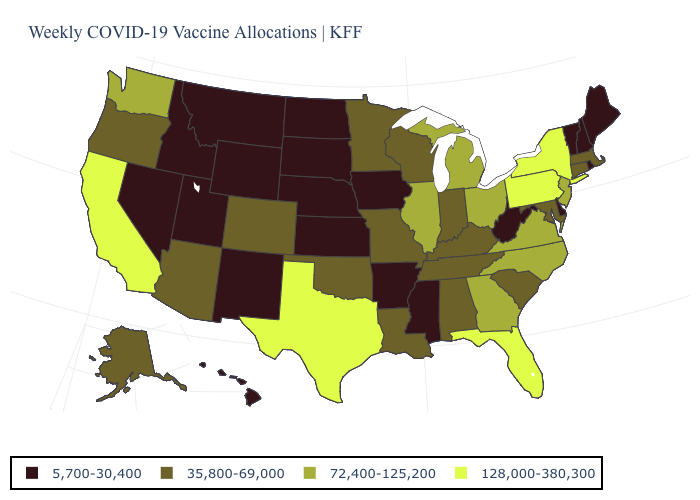What is the value of New York?
Quick response, please. 128,000-380,300. What is the value of Rhode Island?
Concise answer only. 5,700-30,400. Does New Jersey have the same value as Washington?
Be succinct. Yes. What is the value of Ohio?
Quick response, please. 72,400-125,200. Which states have the lowest value in the USA?
Concise answer only. Arkansas, Delaware, Hawaii, Idaho, Iowa, Kansas, Maine, Mississippi, Montana, Nebraska, Nevada, New Hampshire, New Mexico, North Dakota, Rhode Island, South Dakota, Utah, Vermont, West Virginia, Wyoming. Does Pennsylvania have the highest value in the Northeast?
Quick response, please. Yes. Which states hav the highest value in the South?
Short answer required. Florida, Texas. What is the value of California?
Answer briefly. 128,000-380,300. Name the states that have a value in the range 72,400-125,200?
Keep it brief. Georgia, Illinois, Michigan, New Jersey, North Carolina, Ohio, Virginia, Washington. What is the highest value in the Northeast ?
Keep it brief. 128,000-380,300. Does North Carolina have the same value as Wyoming?
Short answer required. No. Name the states that have a value in the range 72,400-125,200?
Be succinct. Georgia, Illinois, Michigan, New Jersey, North Carolina, Ohio, Virginia, Washington. What is the value of Pennsylvania?
Write a very short answer. 128,000-380,300. Among the states that border North Carolina , does Virginia have the highest value?
Answer briefly. Yes. Is the legend a continuous bar?
Give a very brief answer. No. 